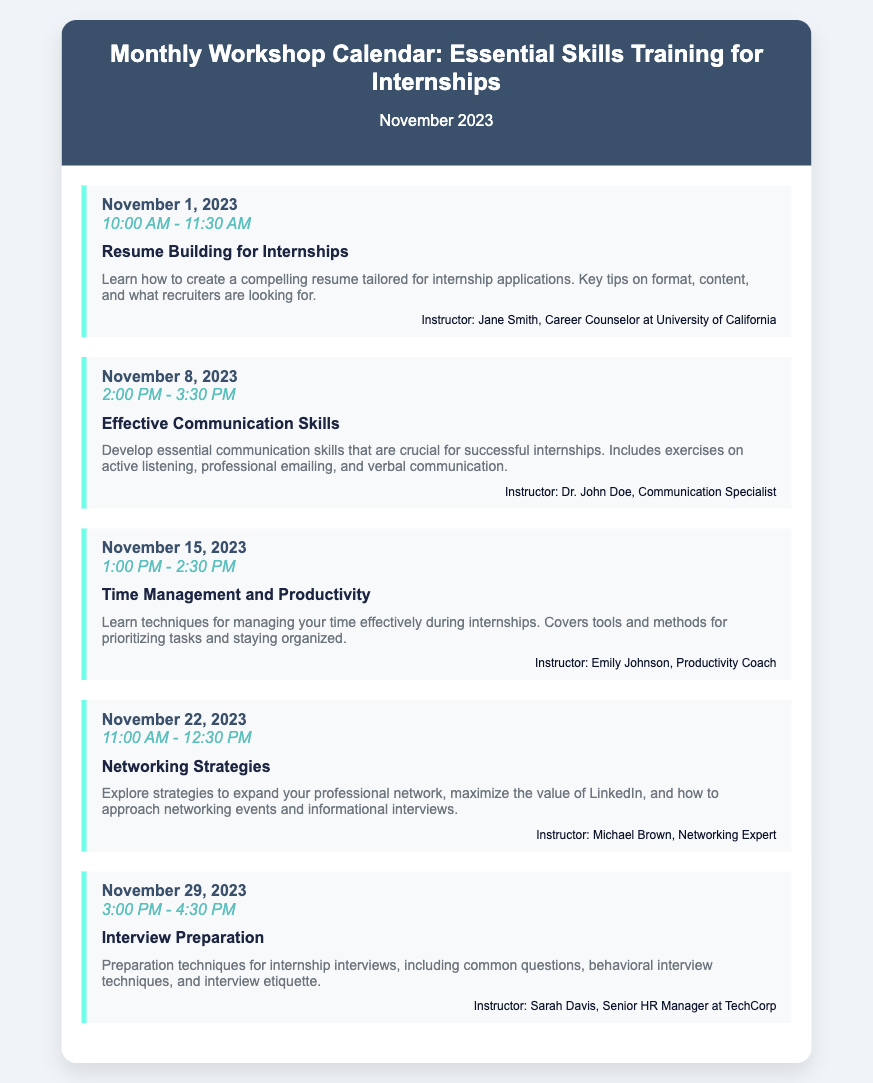What is the date of the first workshop? The first workshop is scheduled for November 1, 2023, as listed in the document.
Answer: November 1, 2023 What is the topic of the workshop on November 15, 2023? The topic of the workshop on November 15, 2023, is explicitly stated in the document as "Time Management and Productivity."
Answer: Time Management and Productivity Who is the instructor for the "Interview Preparation" workshop? The document clearly specifies that the instructor for the "Interview Preparation" workshop is Sarah Davis.
Answer: Sarah Davis How long does the "Effective Communication Skills" workshop last? The duration of the "Effective Communication Skills" workshop is provided, which is from 2:00 PM to 3:30 PM, totaling 1.5 hours.
Answer: 1.5 hours On which date is the "Networking Strategies" workshop scheduled? The date for the "Networking Strategies" workshop is noted in the document as November 22, 2023.
Answer: November 22, 2023 What skill does the workshop on November 1 focus on? The document outlines that the workshop on November 1 focuses on creating a compelling resume for internships.
Answer: Resume Building for Internships How many workshops are scheduled in November 2023? By counting each workshop listed in the document, the total number of workshops can be determined.
Answer: Five What is the time for the "Time Management and Productivity" workshop? The document specifies the time for this workshop as 1:00 PM - 2:30 PM.
Answer: 1:00 PM - 2:30 PM 